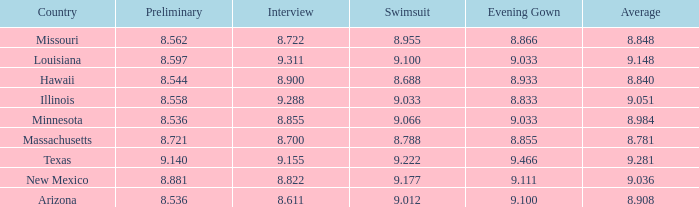What was the swimsuit score for Illinois? 9.033. 